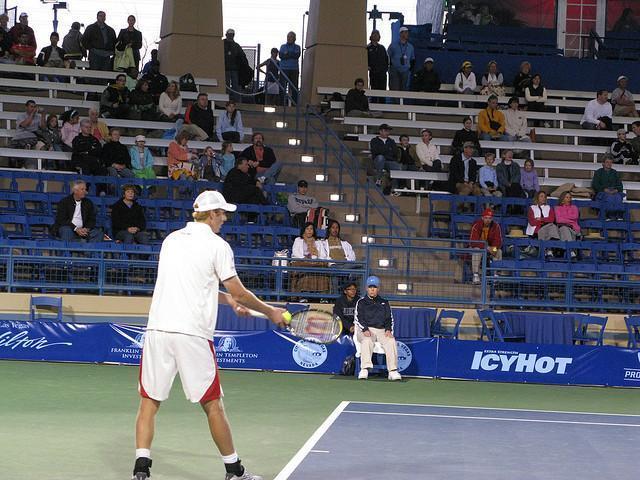How many benches are there?
Give a very brief answer. 3. How many people can you see?
Give a very brief answer. 3. How many horses is in the picture?
Give a very brief answer. 0. 